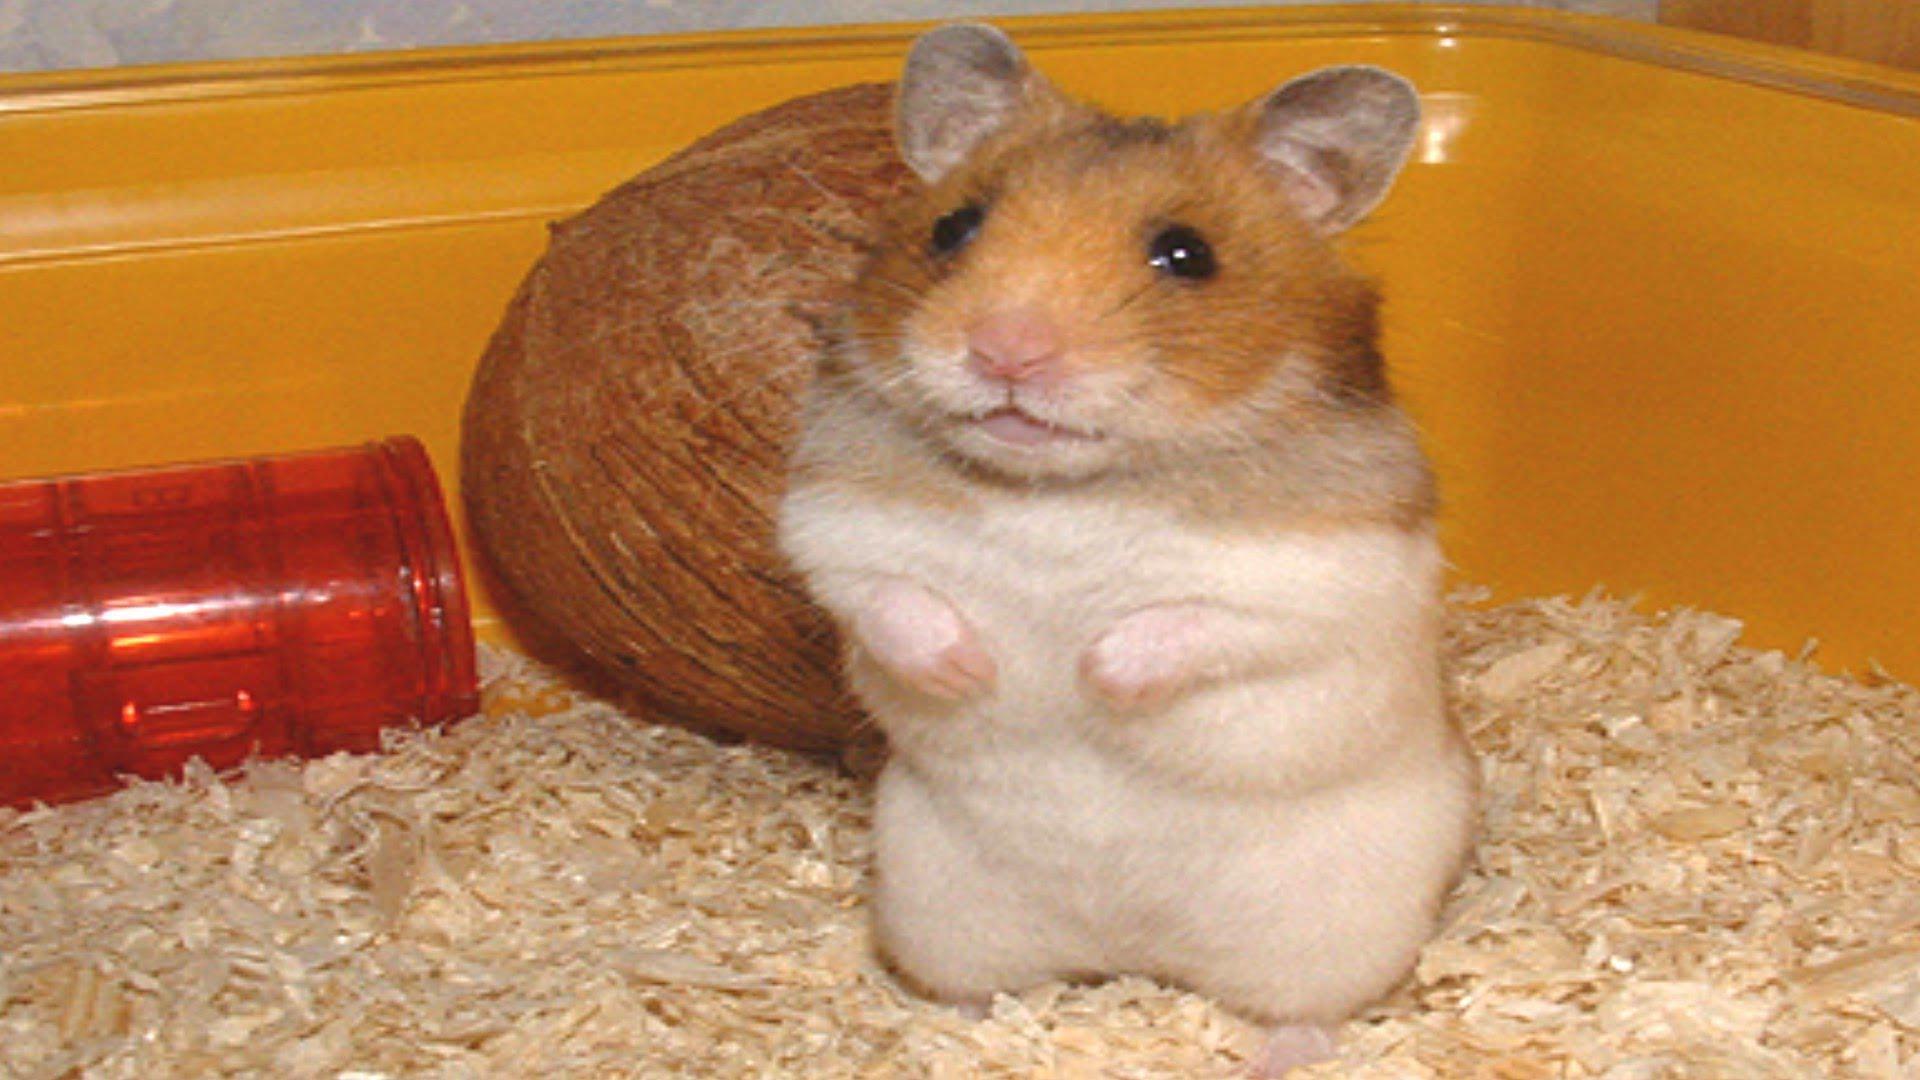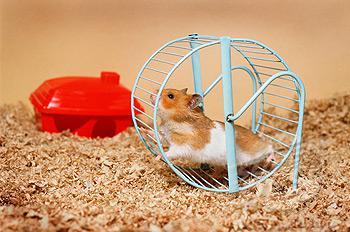The first image is the image on the left, the second image is the image on the right. Considering the images on both sides, is "One image has two mice running in a hamster wheel." valid? Answer yes or no. No. The first image is the image on the left, the second image is the image on the right. Considering the images on both sides, is "the right image has a hamster in a wheel made of blue metal" valid? Answer yes or no. Yes. 